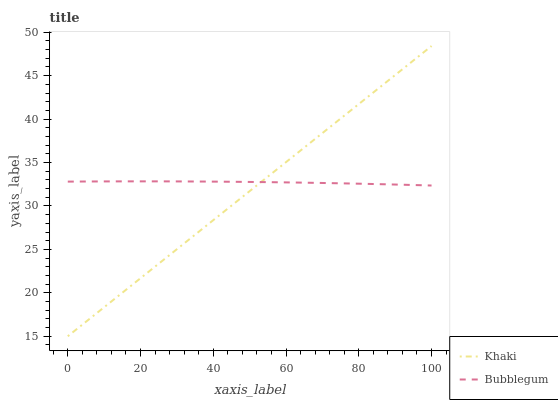Does Khaki have the minimum area under the curve?
Answer yes or no. Yes. Does Bubblegum have the maximum area under the curve?
Answer yes or no. Yes. Does Bubblegum have the minimum area under the curve?
Answer yes or no. No. Is Khaki the smoothest?
Answer yes or no. Yes. Is Bubblegum the roughest?
Answer yes or no. Yes. Is Bubblegum the smoothest?
Answer yes or no. No. Does Khaki have the lowest value?
Answer yes or no. Yes. Does Bubblegum have the lowest value?
Answer yes or no. No. Does Khaki have the highest value?
Answer yes or no. Yes. Does Bubblegum have the highest value?
Answer yes or no. No. Does Bubblegum intersect Khaki?
Answer yes or no. Yes. Is Bubblegum less than Khaki?
Answer yes or no. No. Is Bubblegum greater than Khaki?
Answer yes or no. No. 